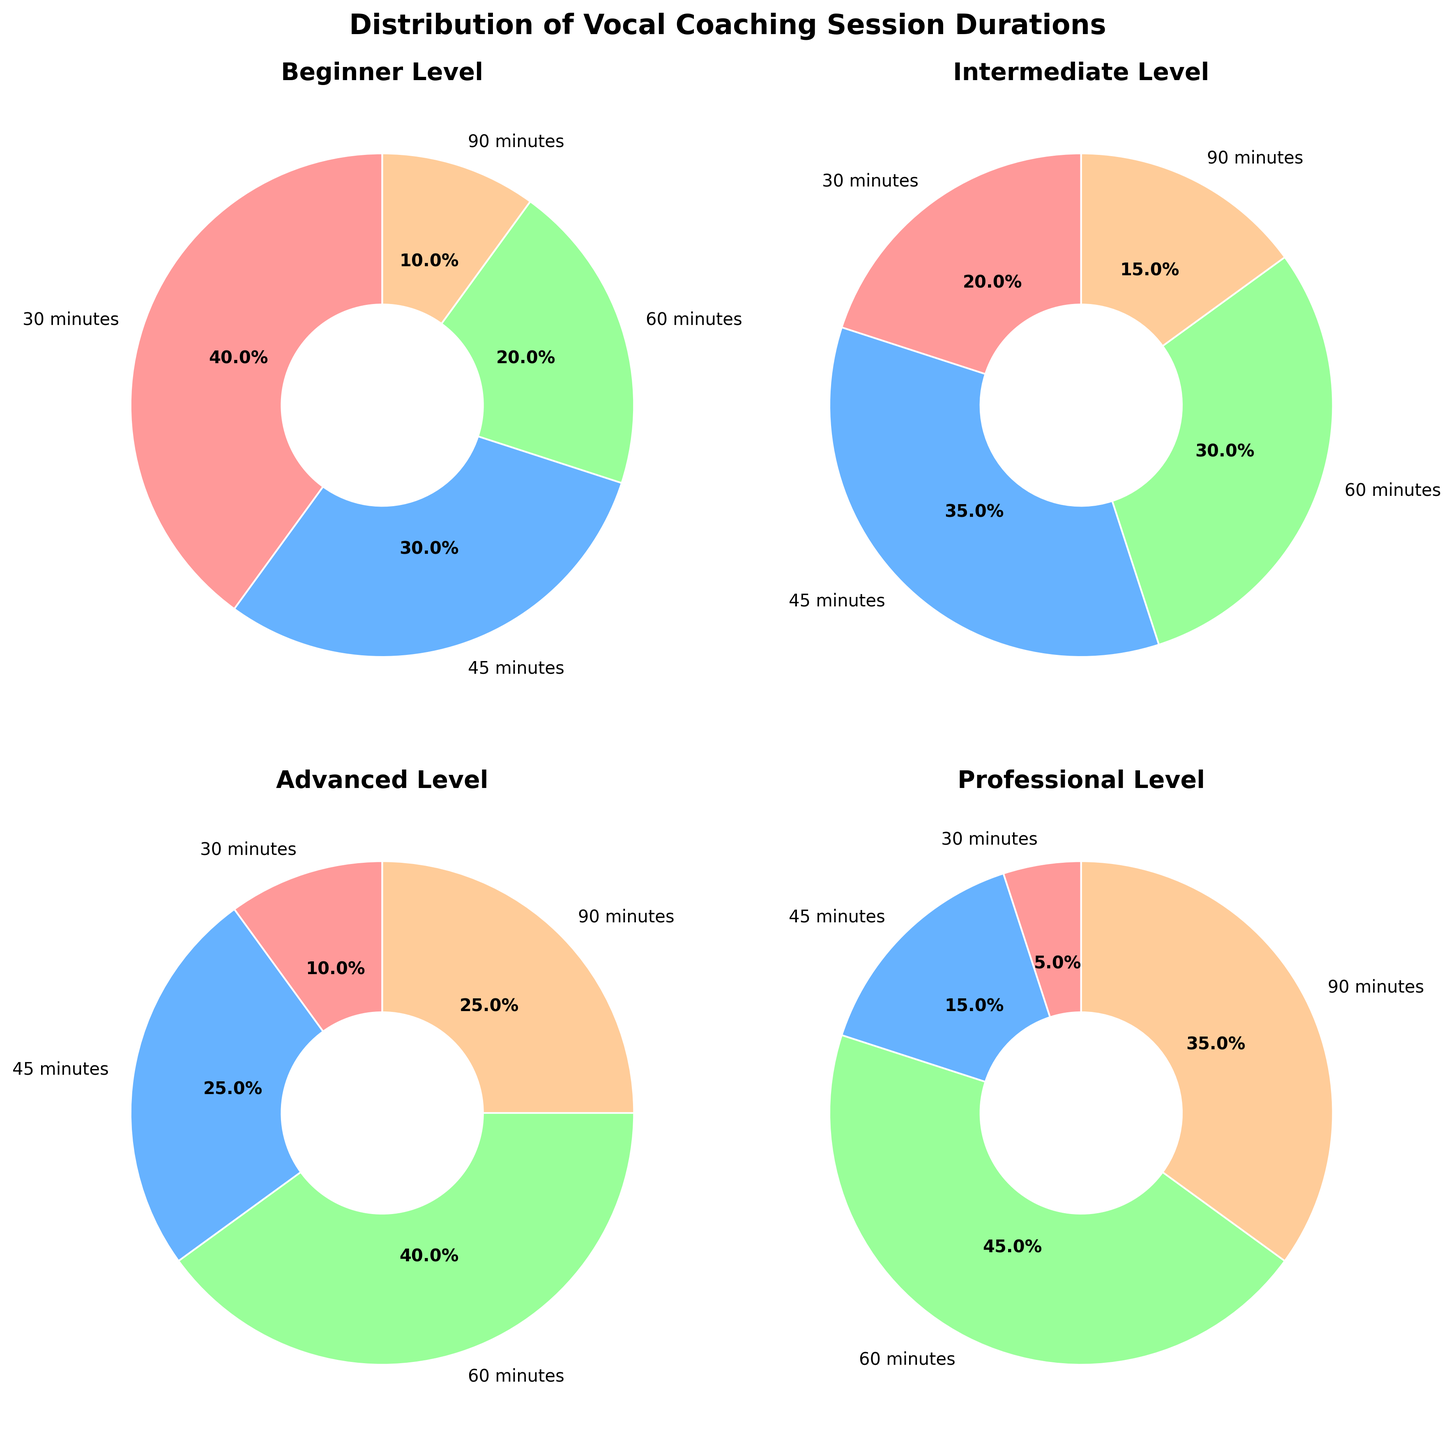What percentage of Beginner sessions are 45 minutes long? We can directly see from the pie chart segment labeled "45 minutes" under the "Beginner Level" subplot that it has a percentage of 30%.
Answer: 30% Which experience level has the highest percentage of sessions lasting 60 minutes? By looking at the pie charts for each experience level, we can compare the sizes and labels of the 60-minute segments. The "Professional Level" subplot shows the 60-minute segment with the largest percentage, which is 45%.
Answer: Professional Which experience level has the most evenly distributed session durations? To determine this, we examine all pie charts to see which one has the most similar-sized segments. The "Intermediate Level" pie chart segments are the closest in size (20%, 35%, 30%, and 15%), indicating an even distribution.
Answer: Intermediate For the Advanced level, what is the combined percentage for sessions lasting 45 minutes and 90 minutes? For the "Advanced Level", we add the percentages of the "45 minutes" (25%) and "90 minutes" (25%) segments. The combined percentage is 25% + 25% = 50%.
Answer: 50% Which session duration appears most frequently across all experience levels? Observing all pie charts, the 60-minute duration shows prominent segments across all levels. By counting eye observations, 60 minutes is most frequent.
Answer: 60 minutes Are there any experience levels where 30-minute sessions represent the smallest percentage of all possible durations? We need to identify pie charts where the smallest segment is labeled "30 minutes". Both "Advanced Level" (10%) and "Professional Level" (5%) meet this criterion.
Answer: Yes What is the difference in percentage between 90-minute sessions for Beginner and Professional levels? Observing the "Beginner Level" and "Professional Level" pie charts, we find the 90-minute segments are 10% and 35%, respectively. The difference in percentage is 35% - 10% = 25%.
Answer: 25% Which experience level has no duration segmented with less than 10 percent? In each pie chart, we verify if any segment is below 10%. The "Intermediate Level" has all segments at or above 15%.
Answer: Intermediate Among Professional sessions, what is the ratio of 45-minute sessions to 90-minute sessions? From the "Professional Level" pie chart, 45-minute sessions are 15%, and 90-minute sessions are 35%. The ratio of 45-minute to 90-minute sessions is 15:35, which simplifies to 3:7.
Answer: 3:7 